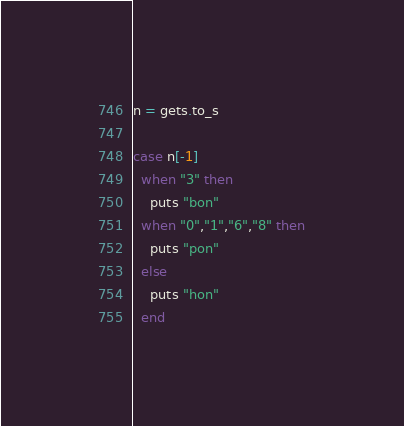<code> <loc_0><loc_0><loc_500><loc_500><_Ruby_>n = gets.to_s

case n[-1]
  when "3" then
    puts "bon"
  when "0","1","6","8" then
    puts "pon"
  else
    puts "hon"
  end</code> 